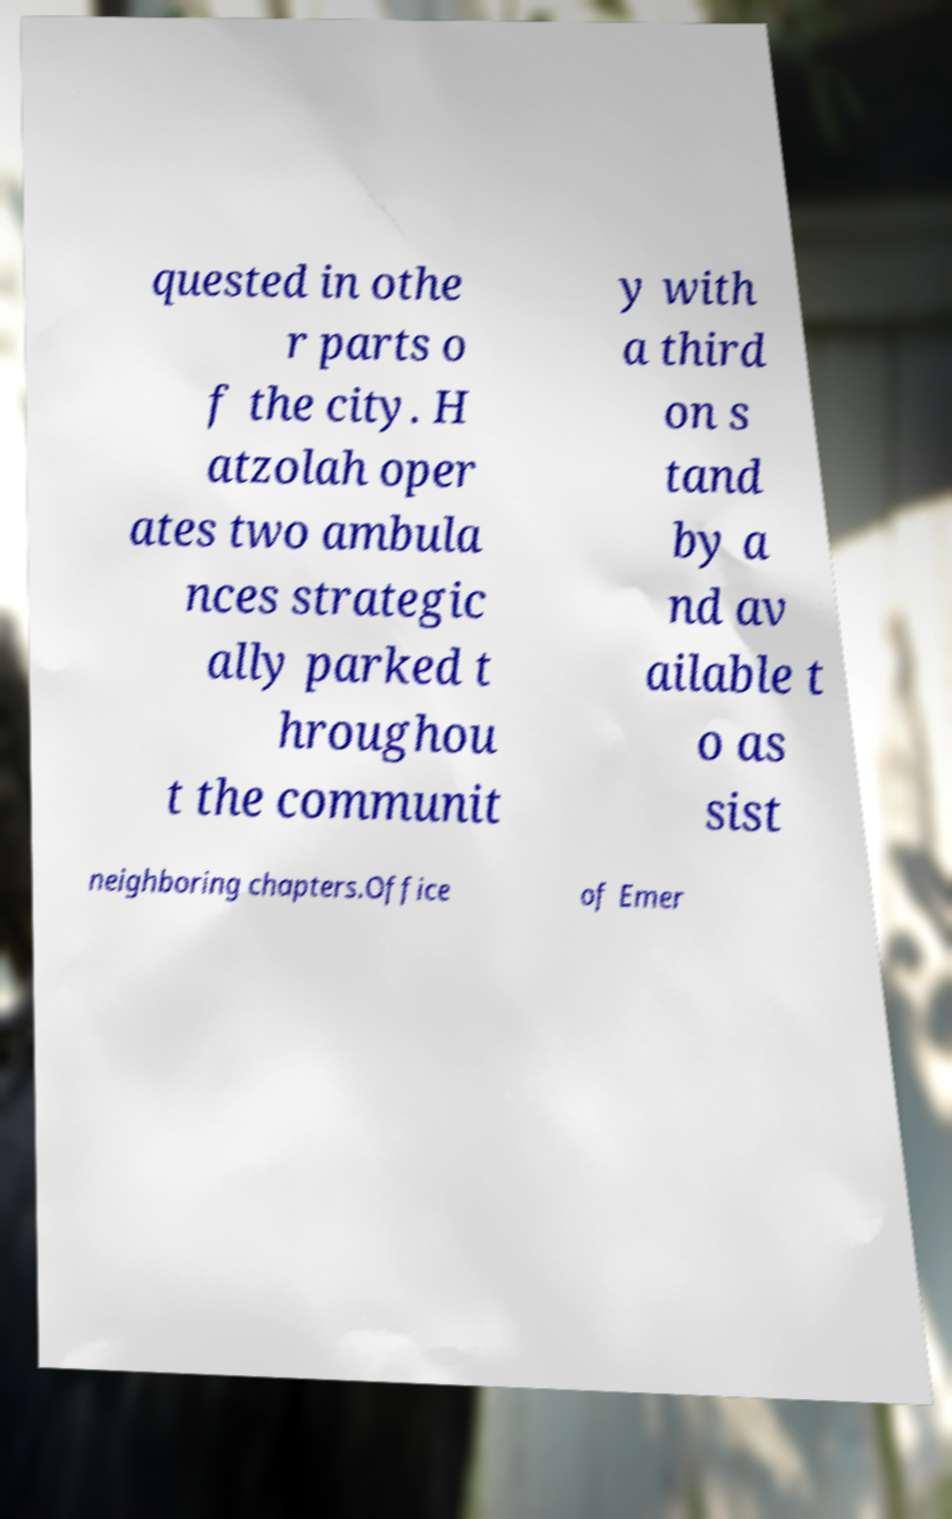Please identify and transcribe the text found in this image. quested in othe r parts o f the city. H atzolah oper ates two ambula nces strategic ally parked t hroughou t the communit y with a third on s tand by a nd av ailable t o as sist neighboring chapters.Office of Emer 